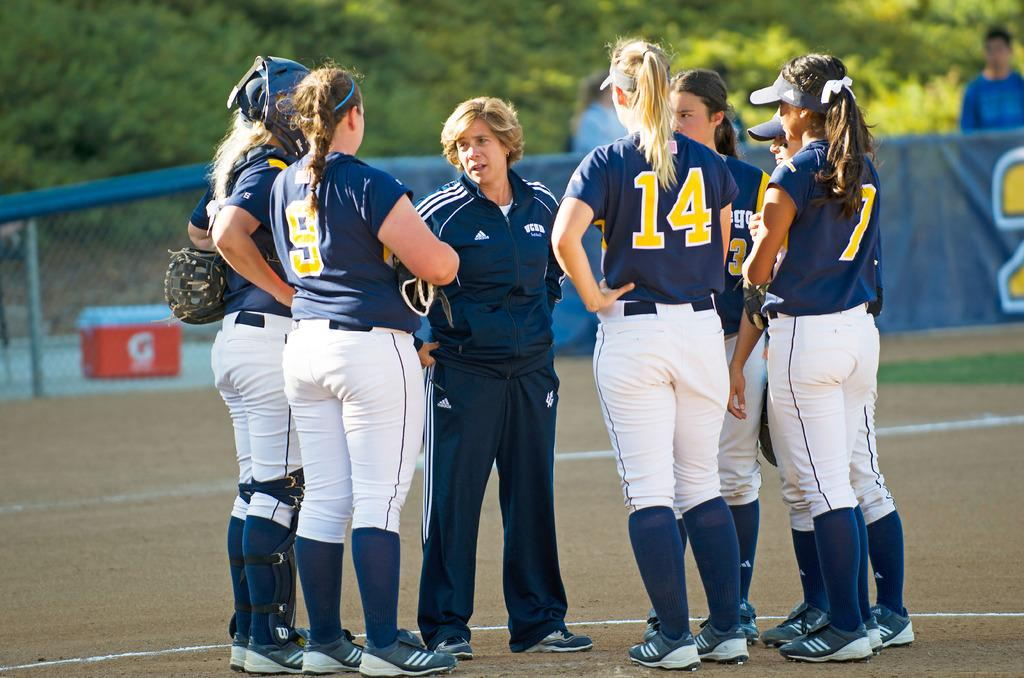<image>
Provide a brief description of the given image. A group of female softball players are huddled around their coach whose jacket says UCBD. 